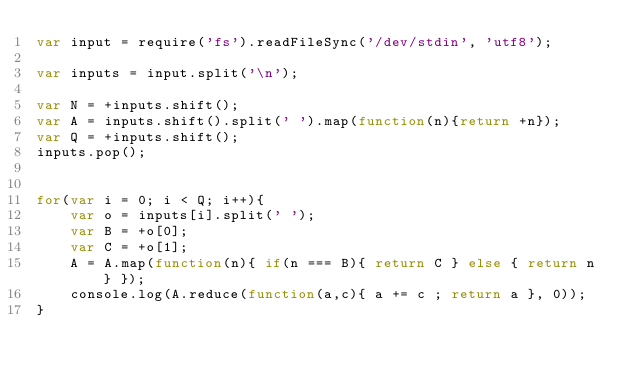<code> <loc_0><loc_0><loc_500><loc_500><_JavaScript_>var input = require('fs').readFileSync('/dev/stdin', 'utf8');

var inputs = input.split('\n');

var N = +inputs.shift();
var A = inputs.shift().split(' ').map(function(n){return +n});
var Q = +inputs.shift();
inputs.pop();


for(var i = 0; i < Q; i++){
    var o = inputs[i].split(' ');
    var B = +o[0];
    var C = +o[1];
    A = A.map(function(n){ if(n === B){ return C } else { return n } });
    console.log(A.reduce(function(a,c){ a += c ; return a }, 0));
}
</code> 